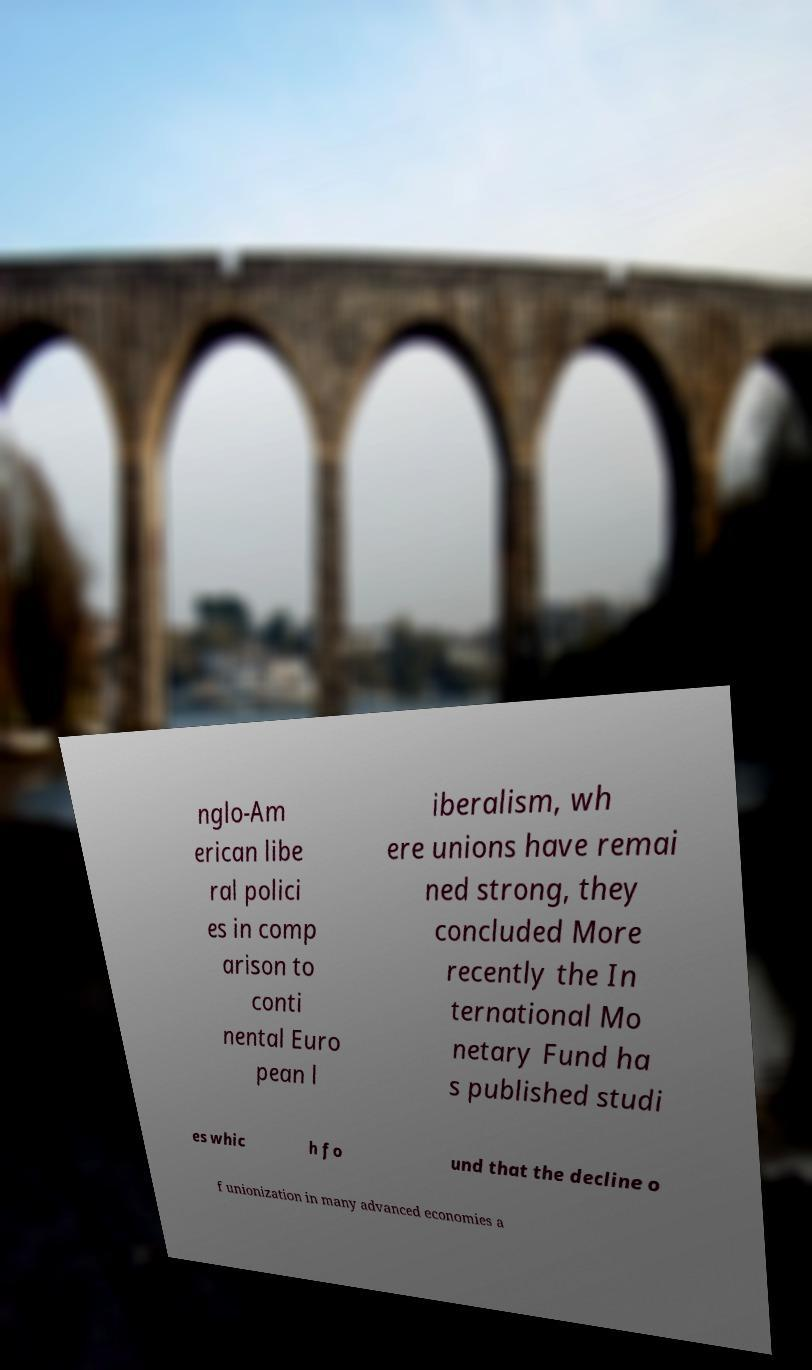Can you read and provide the text displayed in the image?This photo seems to have some interesting text. Can you extract and type it out for me? nglo-Am erican libe ral polici es in comp arison to conti nental Euro pean l iberalism, wh ere unions have remai ned strong, they concluded More recently the In ternational Mo netary Fund ha s published studi es whic h fo und that the decline o f unionization in many advanced economies a 